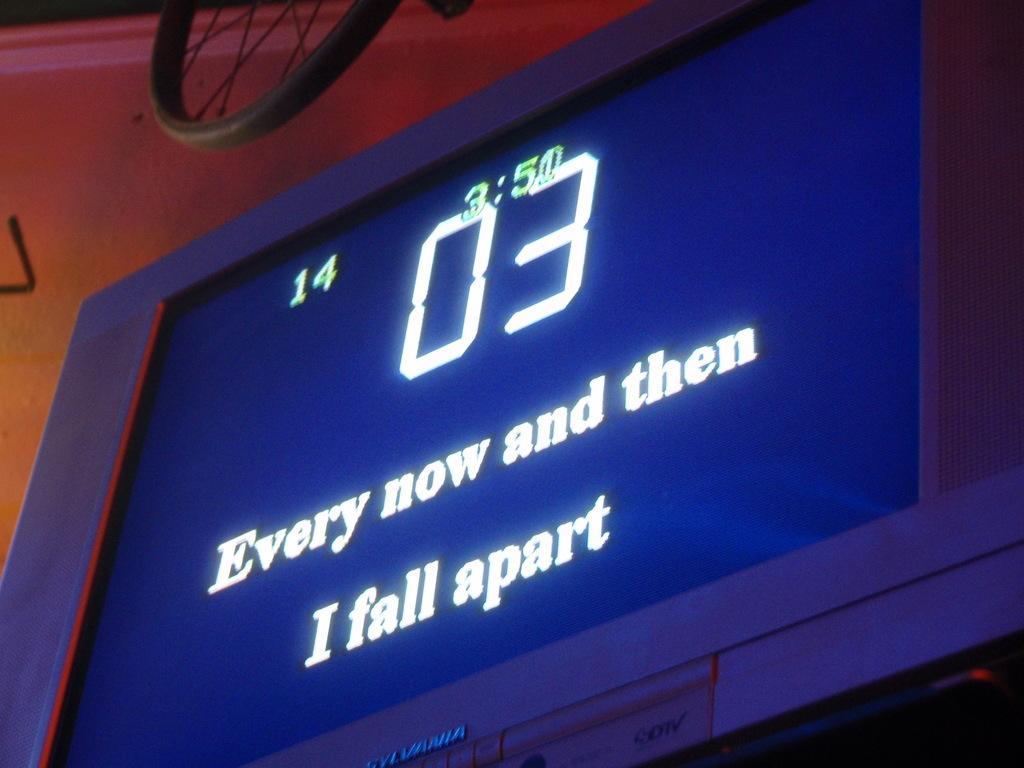<image>
Offer a succinct explanation of the picture presented. A screen stating "Every now and then I fall apart" that is white letters on a blue screen. 